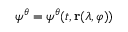<formula> <loc_0><loc_0><loc_500><loc_500>\psi ^ { \theta } = \psi ^ { \theta } ( t , r ( \lambda , \varphi ) )</formula> 